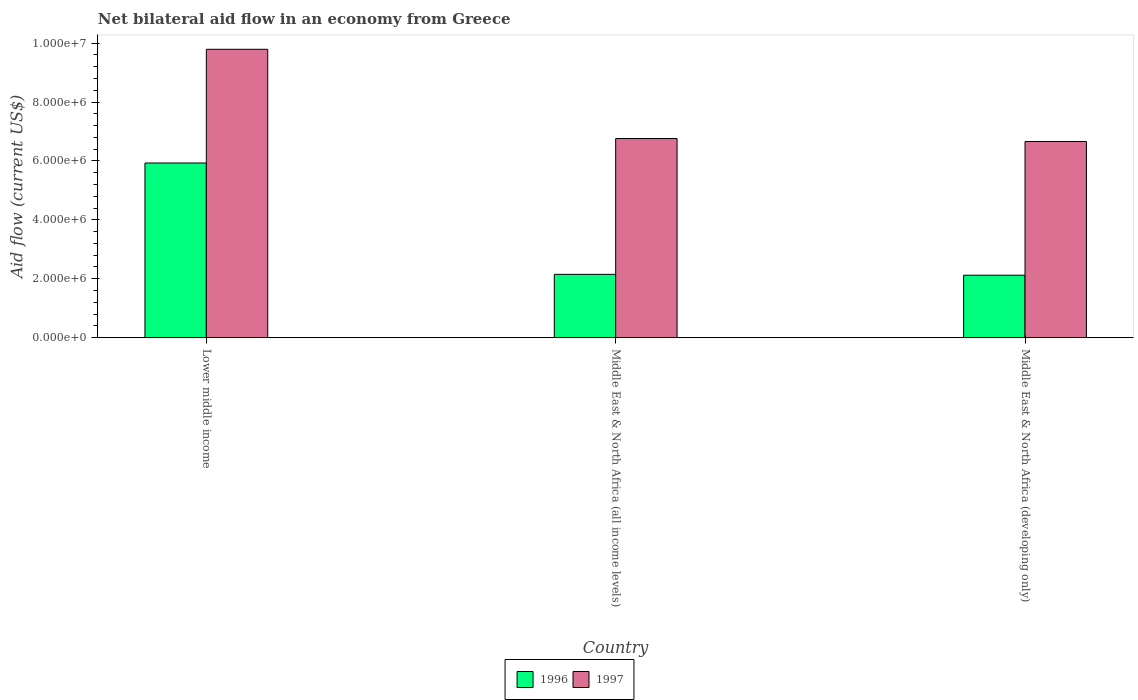Are the number of bars per tick equal to the number of legend labels?
Provide a short and direct response. Yes. Are the number of bars on each tick of the X-axis equal?
Make the answer very short. Yes. How many bars are there on the 1st tick from the left?
Your answer should be compact. 2. How many bars are there on the 3rd tick from the right?
Provide a short and direct response. 2. What is the label of the 1st group of bars from the left?
Offer a very short reply. Lower middle income. In how many cases, is the number of bars for a given country not equal to the number of legend labels?
Your response must be concise. 0. What is the net bilateral aid flow in 1997 in Middle East & North Africa (developing only)?
Your answer should be very brief. 6.66e+06. Across all countries, what is the maximum net bilateral aid flow in 1997?
Offer a very short reply. 9.79e+06. Across all countries, what is the minimum net bilateral aid flow in 1996?
Offer a very short reply. 2.12e+06. In which country was the net bilateral aid flow in 1997 maximum?
Offer a very short reply. Lower middle income. In which country was the net bilateral aid flow in 1997 minimum?
Your answer should be very brief. Middle East & North Africa (developing only). What is the total net bilateral aid flow in 1996 in the graph?
Your response must be concise. 1.02e+07. What is the difference between the net bilateral aid flow in 1997 in Middle East & North Africa (all income levels) and that in Middle East & North Africa (developing only)?
Give a very brief answer. 1.00e+05. What is the difference between the net bilateral aid flow in 1997 in Middle East & North Africa (developing only) and the net bilateral aid flow in 1996 in Lower middle income?
Give a very brief answer. 7.30e+05. What is the average net bilateral aid flow in 1997 per country?
Make the answer very short. 7.74e+06. What is the difference between the net bilateral aid flow of/in 1996 and net bilateral aid flow of/in 1997 in Middle East & North Africa (all income levels)?
Your answer should be compact. -4.61e+06. In how many countries, is the net bilateral aid flow in 1997 greater than 400000 US$?
Give a very brief answer. 3. What is the ratio of the net bilateral aid flow in 1996 in Lower middle income to that in Middle East & North Africa (all income levels)?
Provide a short and direct response. 2.76. What is the difference between the highest and the second highest net bilateral aid flow in 1996?
Provide a succinct answer. 3.81e+06. What is the difference between the highest and the lowest net bilateral aid flow in 1997?
Make the answer very short. 3.13e+06. In how many countries, is the net bilateral aid flow in 1996 greater than the average net bilateral aid flow in 1996 taken over all countries?
Provide a succinct answer. 1. Is the sum of the net bilateral aid flow in 1996 in Lower middle income and Middle East & North Africa (developing only) greater than the maximum net bilateral aid flow in 1997 across all countries?
Provide a succinct answer. No. How many bars are there?
Make the answer very short. 6. How many countries are there in the graph?
Your response must be concise. 3. What is the difference between two consecutive major ticks on the Y-axis?
Offer a very short reply. 2.00e+06. Does the graph contain any zero values?
Provide a short and direct response. No. Where does the legend appear in the graph?
Offer a very short reply. Bottom center. How are the legend labels stacked?
Provide a succinct answer. Horizontal. What is the title of the graph?
Provide a short and direct response. Net bilateral aid flow in an economy from Greece. What is the Aid flow (current US$) in 1996 in Lower middle income?
Offer a very short reply. 5.93e+06. What is the Aid flow (current US$) of 1997 in Lower middle income?
Offer a terse response. 9.79e+06. What is the Aid flow (current US$) of 1996 in Middle East & North Africa (all income levels)?
Provide a succinct answer. 2.15e+06. What is the Aid flow (current US$) of 1997 in Middle East & North Africa (all income levels)?
Make the answer very short. 6.76e+06. What is the Aid flow (current US$) of 1996 in Middle East & North Africa (developing only)?
Keep it short and to the point. 2.12e+06. What is the Aid flow (current US$) of 1997 in Middle East & North Africa (developing only)?
Ensure brevity in your answer.  6.66e+06. Across all countries, what is the maximum Aid flow (current US$) of 1996?
Offer a very short reply. 5.93e+06. Across all countries, what is the maximum Aid flow (current US$) in 1997?
Give a very brief answer. 9.79e+06. Across all countries, what is the minimum Aid flow (current US$) in 1996?
Give a very brief answer. 2.12e+06. Across all countries, what is the minimum Aid flow (current US$) of 1997?
Make the answer very short. 6.66e+06. What is the total Aid flow (current US$) of 1996 in the graph?
Offer a very short reply. 1.02e+07. What is the total Aid flow (current US$) of 1997 in the graph?
Provide a succinct answer. 2.32e+07. What is the difference between the Aid flow (current US$) in 1996 in Lower middle income and that in Middle East & North Africa (all income levels)?
Give a very brief answer. 3.78e+06. What is the difference between the Aid flow (current US$) in 1997 in Lower middle income and that in Middle East & North Africa (all income levels)?
Make the answer very short. 3.03e+06. What is the difference between the Aid flow (current US$) in 1996 in Lower middle income and that in Middle East & North Africa (developing only)?
Keep it short and to the point. 3.81e+06. What is the difference between the Aid flow (current US$) in 1997 in Lower middle income and that in Middle East & North Africa (developing only)?
Your response must be concise. 3.13e+06. What is the difference between the Aid flow (current US$) of 1996 in Middle East & North Africa (all income levels) and that in Middle East & North Africa (developing only)?
Your response must be concise. 3.00e+04. What is the difference between the Aid flow (current US$) in 1996 in Lower middle income and the Aid flow (current US$) in 1997 in Middle East & North Africa (all income levels)?
Provide a short and direct response. -8.30e+05. What is the difference between the Aid flow (current US$) of 1996 in Lower middle income and the Aid flow (current US$) of 1997 in Middle East & North Africa (developing only)?
Make the answer very short. -7.30e+05. What is the difference between the Aid flow (current US$) in 1996 in Middle East & North Africa (all income levels) and the Aid flow (current US$) in 1997 in Middle East & North Africa (developing only)?
Provide a short and direct response. -4.51e+06. What is the average Aid flow (current US$) of 1996 per country?
Keep it short and to the point. 3.40e+06. What is the average Aid flow (current US$) in 1997 per country?
Make the answer very short. 7.74e+06. What is the difference between the Aid flow (current US$) of 1996 and Aid flow (current US$) of 1997 in Lower middle income?
Offer a very short reply. -3.86e+06. What is the difference between the Aid flow (current US$) of 1996 and Aid flow (current US$) of 1997 in Middle East & North Africa (all income levels)?
Your answer should be very brief. -4.61e+06. What is the difference between the Aid flow (current US$) of 1996 and Aid flow (current US$) of 1997 in Middle East & North Africa (developing only)?
Your answer should be very brief. -4.54e+06. What is the ratio of the Aid flow (current US$) in 1996 in Lower middle income to that in Middle East & North Africa (all income levels)?
Keep it short and to the point. 2.76. What is the ratio of the Aid flow (current US$) of 1997 in Lower middle income to that in Middle East & North Africa (all income levels)?
Provide a short and direct response. 1.45. What is the ratio of the Aid flow (current US$) in 1996 in Lower middle income to that in Middle East & North Africa (developing only)?
Your answer should be compact. 2.8. What is the ratio of the Aid flow (current US$) in 1997 in Lower middle income to that in Middle East & North Africa (developing only)?
Ensure brevity in your answer.  1.47. What is the ratio of the Aid flow (current US$) in 1996 in Middle East & North Africa (all income levels) to that in Middle East & North Africa (developing only)?
Make the answer very short. 1.01. What is the difference between the highest and the second highest Aid flow (current US$) of 1996?
Your answer should be very brief. 3.78e+06. What is the difference between the highest and the second highest Aid flow (current US$) in 1997?
Keep it short and to the point. 3.03e+06. What is the difference between the highest and the lowest Aid flow (current US$) in 1996?
Give a very brief answer. 3.81e+06. What is the difference between the highest and the lowest Aid flow (current US$) in 1997?
Your answer should be very brief. 3.13e+06. 